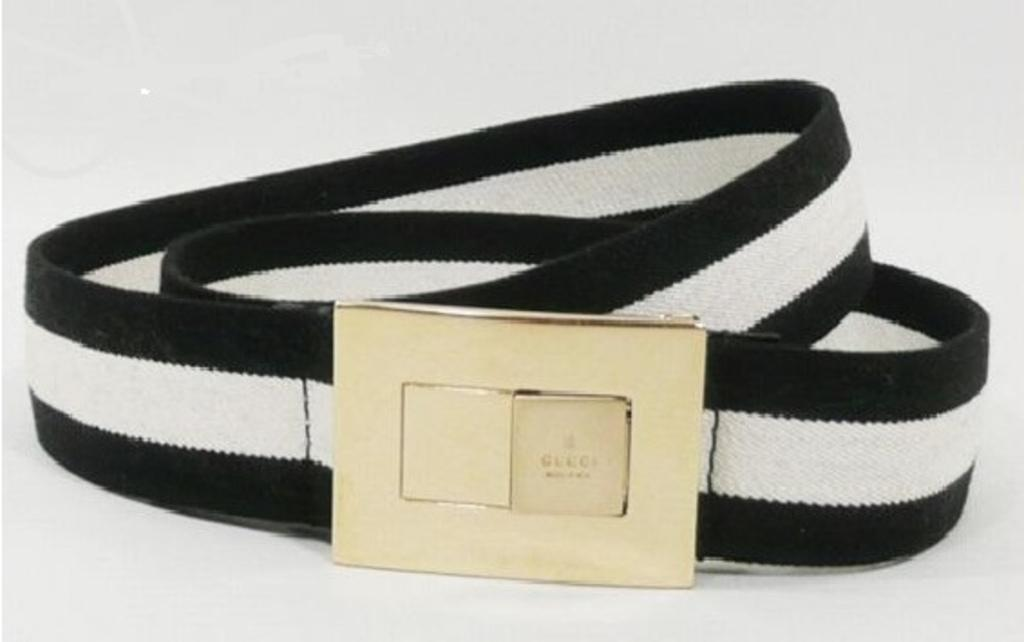What object can be seen in the image? There is a belt in the image. What colors are present on the belt? The belt is black and white in color. What is attached to the belt? There is a buckle attached to the belt. What color is the background of the image? The background of the image is white in color. Can you see the father pushing a ball in the image? There is no father or ball present in the image; it only features a belt with a buckle against a white background. 